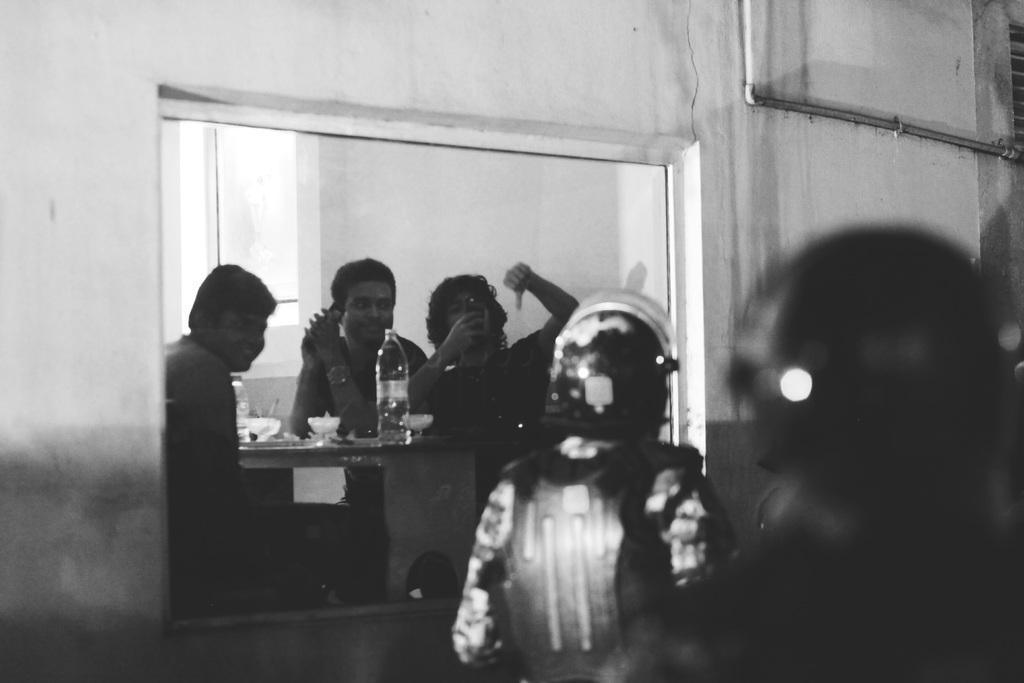Describe this image in one or two sentences. This image consists of few persons. In the front, we can see a table on which there are bottles and cups. On the left, we can see a wall in white color. In the background it looks like a window. 